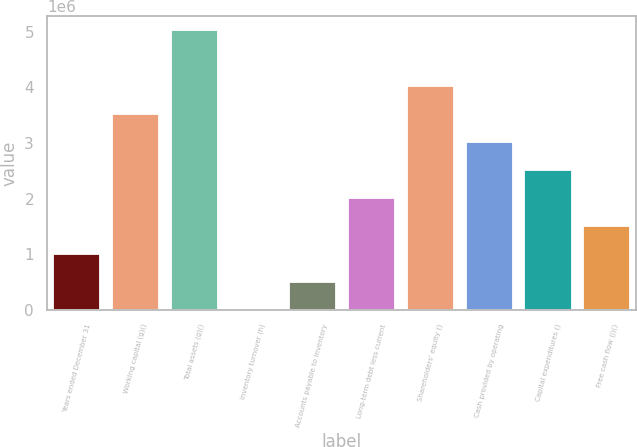<chart> <loc_0><loc_0><loc_500><loc_500><bar_chart><fcel>Years ended December 31<fcel>Working capital (g)()<fcel>Total assets (g)()<fcel>Inventory turnover (h)<fcel>Accounts payable to inventory<fcel>Long-term debt less current<fcel>Shareholders' equity ()<fcel>Cash provided by operating<fcel>Capital expenditures ()<fcel>Free cash flow (j)()<nl><fcel>1.00639e+06<fcel>3.52237e+06<fcel>5.03195e+06<fcel>1.4<fcel>503196<fcel>2.01278e+06<fcel>4.02556e+06<fcel>3.01917e+06<fcel>2.51598e+06<fcel>1.50959e+06<nl></chart> 